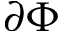<formula> <loc_0><loc_0><loc_500><loc_500>\partial \Phi</formula> 